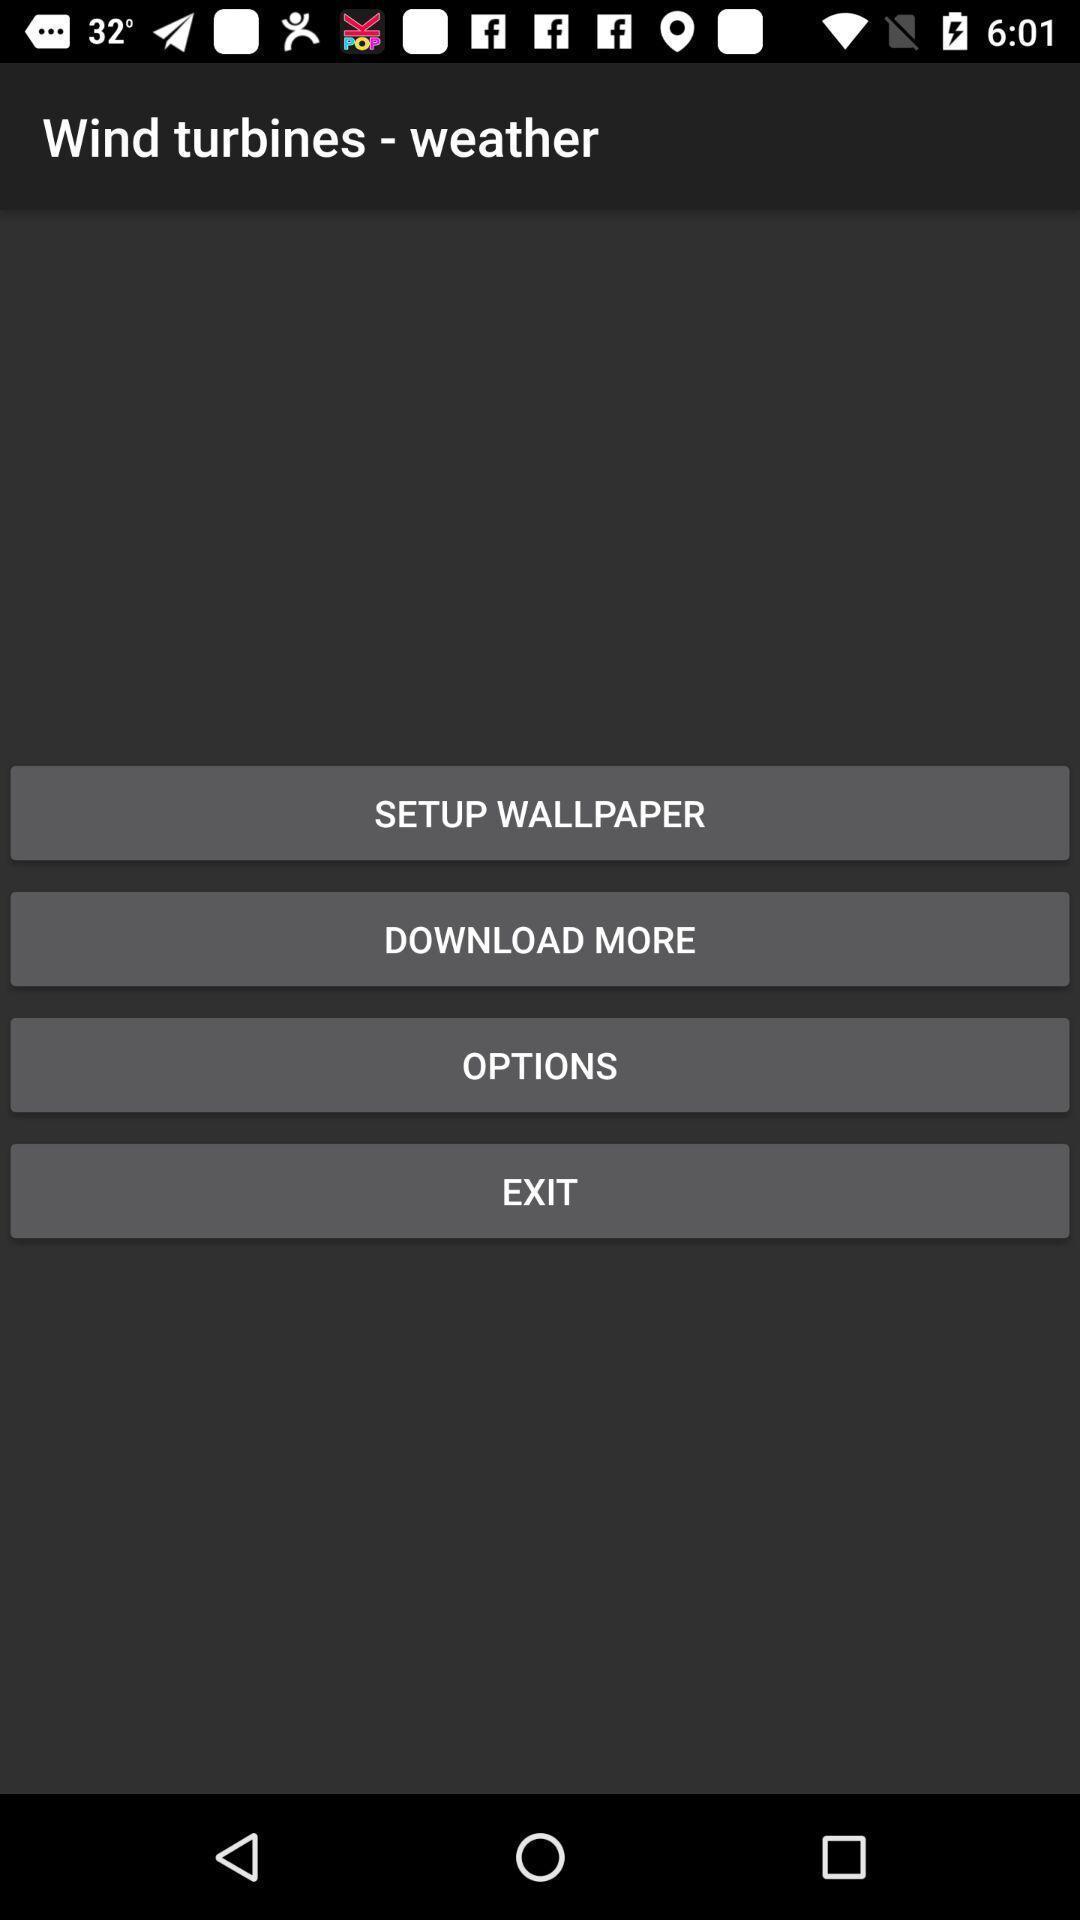Provide a textual representation of this image. Page showing different options on an app. 